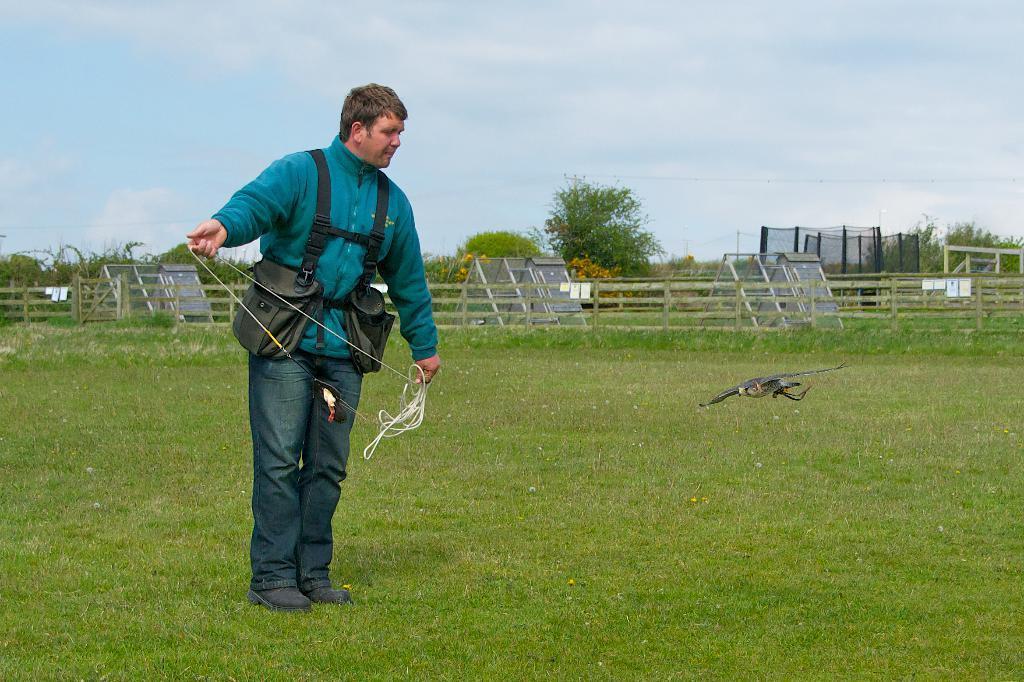Describe this image in one or two sentences. In this image, I can see the man standing and holding a rope. He wore a jerkin, trouser and shoes. These are the bags. This looks like a wooden fence. I think this is a kind of a drone flying. These are the small sheds. I can see the trees. Here is the grass. 